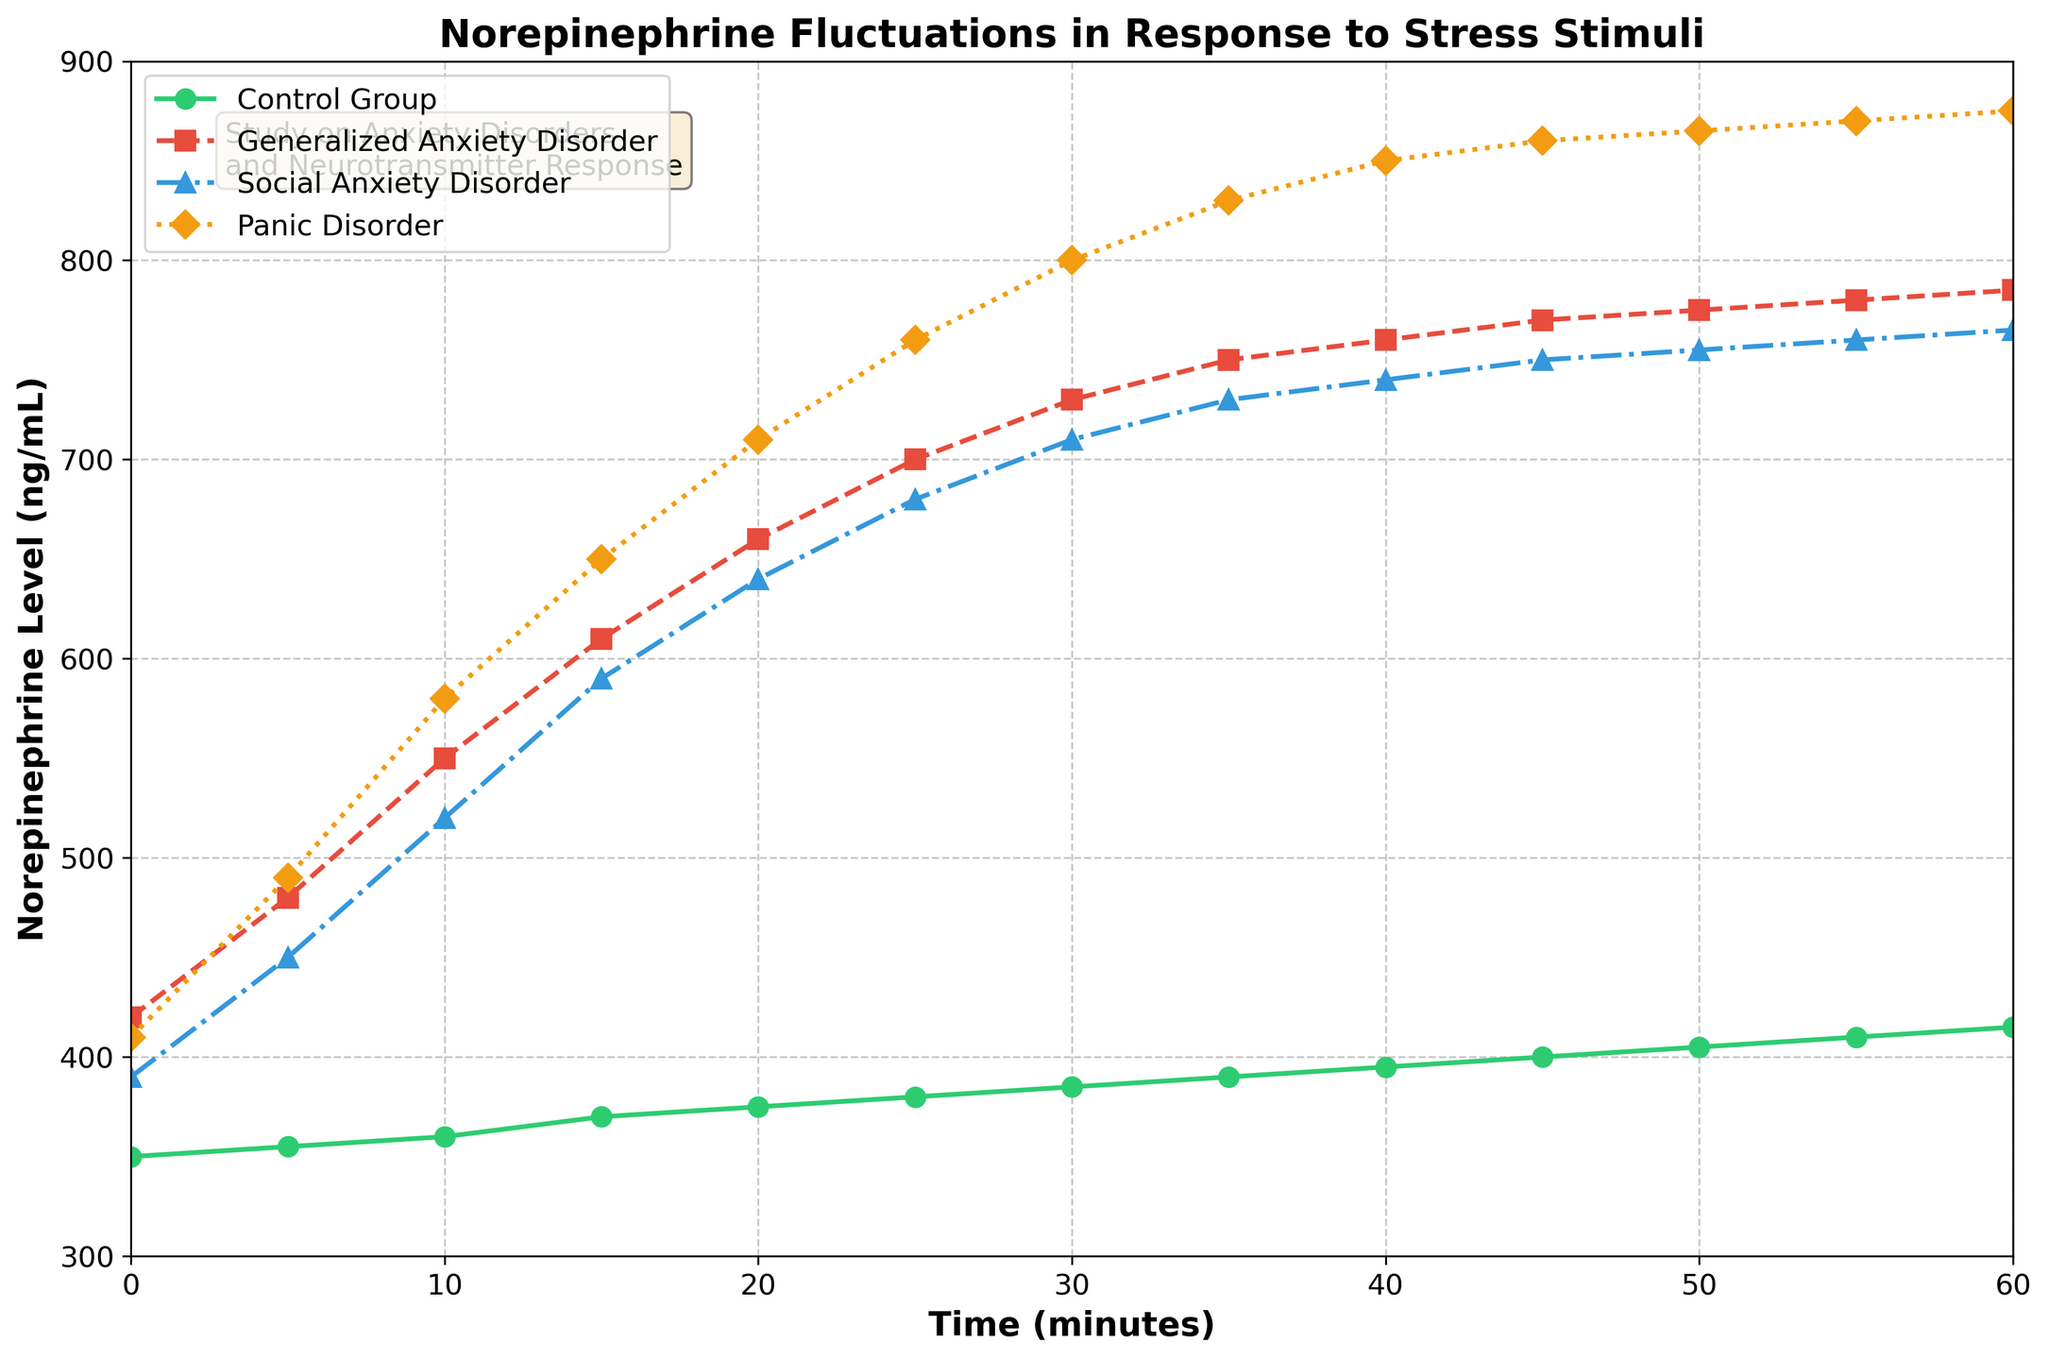What is the norepinephrine level for the Generalized Anxiety Disorder group at minute 30? The Generalized Anxiety Disorder line is drawn with red squares. At the 30-minute mark, trace vertically upward from 30 on the x-axis to find the point, and then move horizontally to find the value on the y-axis.
Answer: 730 ng/mL Which group shows the highest increase in norepinephrine levels between 0 and 60 minutes? To determine this, you need to calculate the norepinephrine increase for each group over this time period by subtracting the 0-minute level from the 60-minute level. For Control Group: 415 - 350 = 65 ng/mL, Generalized Anxiety Disorder: 785 - 420 = 365 ng/mL, Social Anxiety Disorder: 765 - 390 = 375 ng/mL, Panic Disorder: 875 - 410 = 465 ng/mL. The Panic Disorder group shows the highest increase.
Answer: Panic Disorder What is the average norepinephrine level for the Control Group over the 60 minutes? To get the mean value, sum up all the values for the Control Group and divide by the number of time points. Mean = (350 + 355 + 360 + 370 + 375 + 380 + 385 + 390 + 395 + 400 + 405 + 410 + 415) / 13 = 5025 / 13
Answer: 386.538 ng/mL Compare the norepinephrine level between Social Anxiety Disorder and Panic Disorder at the 20-minute mark. Which is higher? Identify the values for Social Anxiety Disorder and Panic Disorder at 20 minutes. Social Anxiety Disorder: 640 ng/mL, Panic Disorder: 710 ng/mL. Compare the two values.
Answer: Panic Disorder What is the pattern of norepinephrine levels for the Control Group over time? The green circles representing the Control Group show a consistently gradual and linear increase from 350 ng/mL at 0 minutes to 415 ng/mL at 60 minutes. There are no sharp spikes or drastic changes.
Answer: Gradual increase How many minutes does it take for the norepinephrine level of the Generalized Anxiety Disorder group to exceed 700 ng/mL? Identify the first time point where the Generalized Anxiety Disorder (red squares) norepinephrine level is greater than 700 ng/mL. This happens at 25 minutes (700 ng/mL).
Answer: 25 minutes By how much does the norepinephrine level change for Panic Disorder from 25 to 35 minutes? Find the difference between the norepinephrine levels for Panic Disorder at 35 minutes and 25 minutes. At 35 minutes: 830 ng/mL, at 25 minutes: 760 ng/mL. Change = 830 - 760 = 70 ng/mL.
Answer: 70 ng/mL Which group has the steepest increase in norepinephrine levels between 0 and 20 minutes? Calculate the increase for each group over this period and observe the slope steepness. Control Group: 375 - 350 = 25 ng/mL, Generalized Anxiety Disorder: 660 - 420 = 240 ng/mL, Social Anxiety Disorder: 640 - 390 = 250 ng/mL, Panic Disorder: 710 - 410 = 300 ng/mL. The Panic Disorder group has the steepest increase.
Answer: Panic Disorder Are the norepinephrine levels for any groups equal at any time point? Visually inspect the plot for overlapping points with the same y-axis value across different groups. No two lines intersect, meaning no group has identical levels at the same time point.
Answer: No 